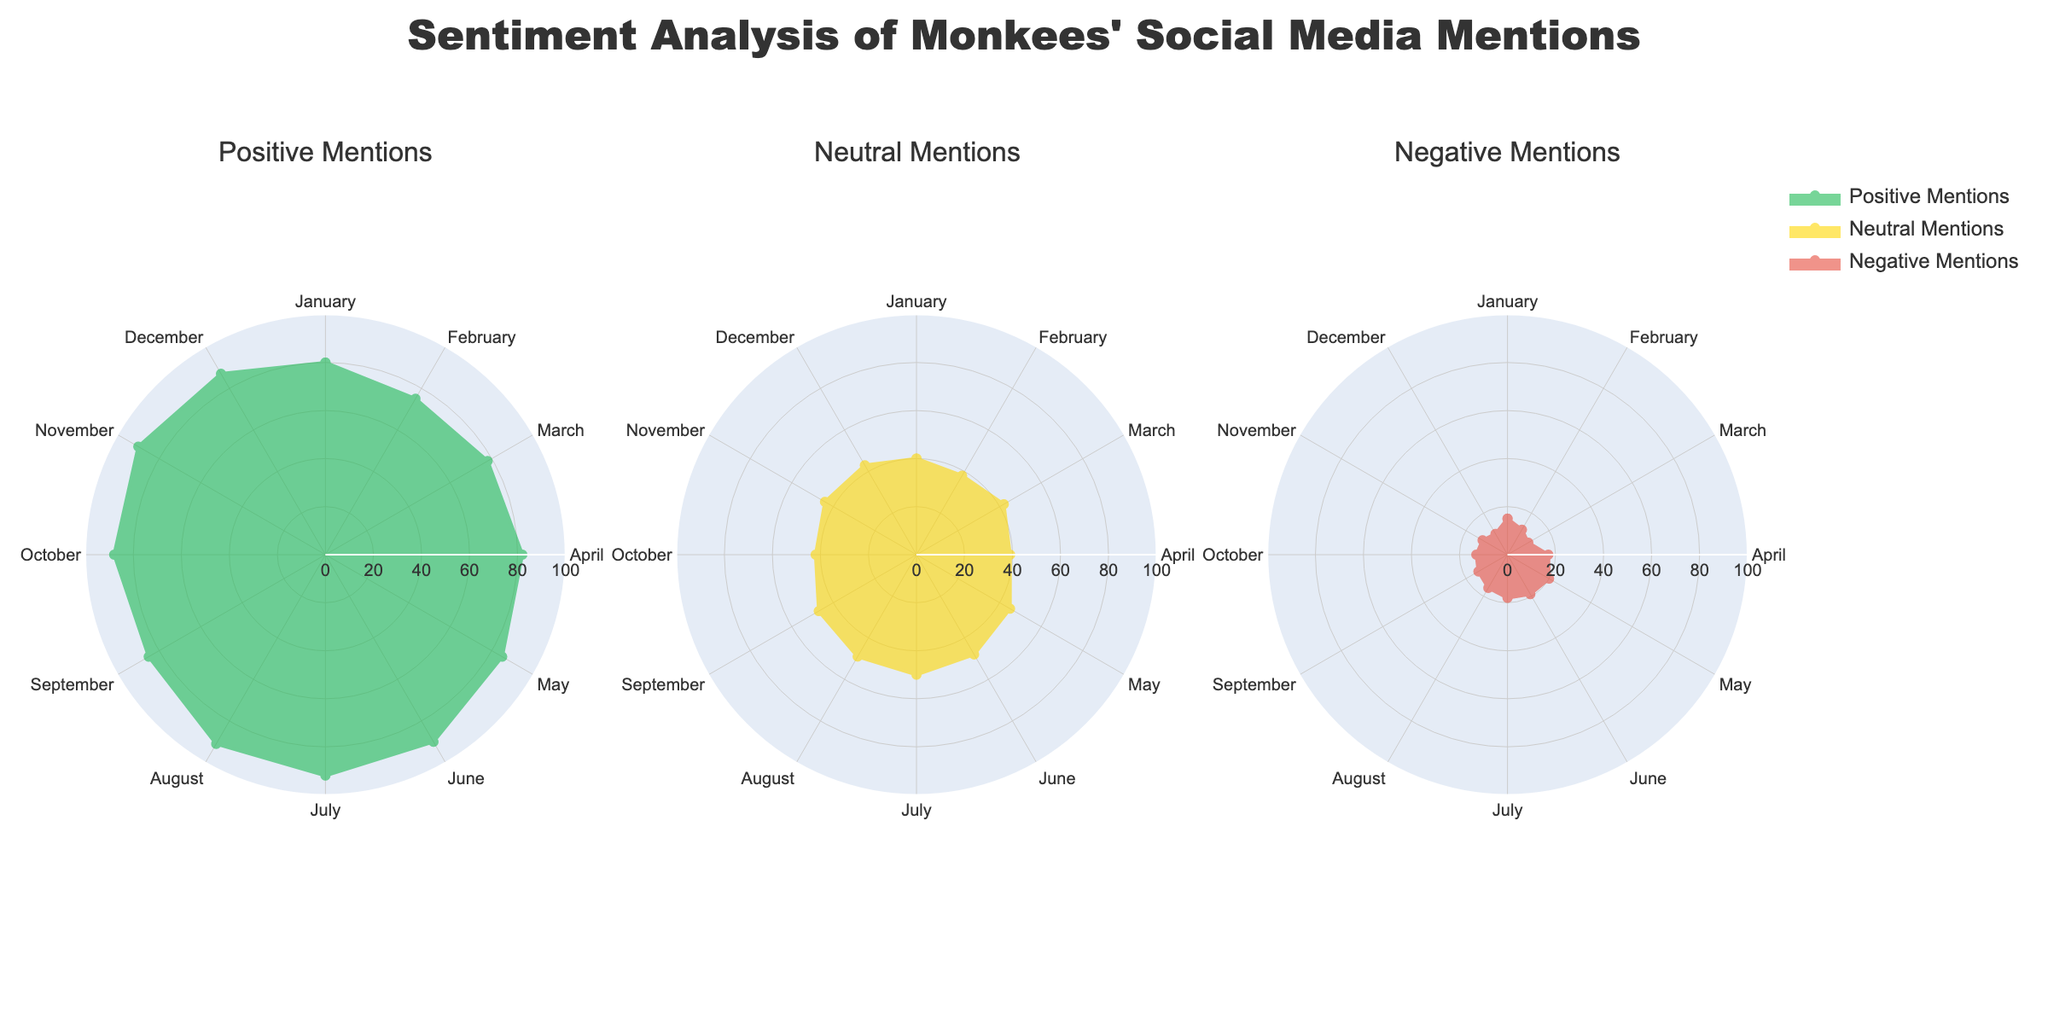What is the title of the radar chart? The title of the radar chart is displayed at the top center. It reads "Sentiment Analysis of Monkees' Social Media Mentions."
Answer: Sentiment Analysis of Monkees' Social Media Mentions How many categories of mentions are analyzed in the radar charts? The radar charts analyze three categories of mentions: Positive, Neutral, and Negative.
Answer: Three Which category had the highest number of mentions in July? By looking at the height of the data points in the radar chart specific to July, it's evident that "Positive Mentions" had the highest value.
Answer: Positive Mentions Which month had the lowest number of Neutral mentions? By observing the radar chart displaying Neutral Mentions, February has the lowest value of Neutral Mentions.
Answer: February Compare the number of Positive Mentions in January and December. Which one is higher? In the radar chart for Positive Mentions, it shows that December has 87 mentions while January has 80, making December higher.
Answer: December What is the range of values for Negative Mentions throughout the year? By examining the values in the radar chart for Negative Mentions, the highest is 20 and the lowest is 10, giving a range of 20 - 10 = 10.
Answer: 10 What is the average number of Positive Mentions over the year? Sum up the numbers of Positive Mentions for each month: 80 + 75 + 78 + 82 + 85 + 90 + 92 + 91 + 85 + 88 + 90 + 87 = 1023. Divide by 12 (number of months): 1023/12 = 85.25.
Answer: 85.25 How do Negative Mentions in March compare to those in November? From the radar chart for Negative Mentions, November has 12 mentions and March has 10. Comparing them, March is less than November.
Answer: Less 